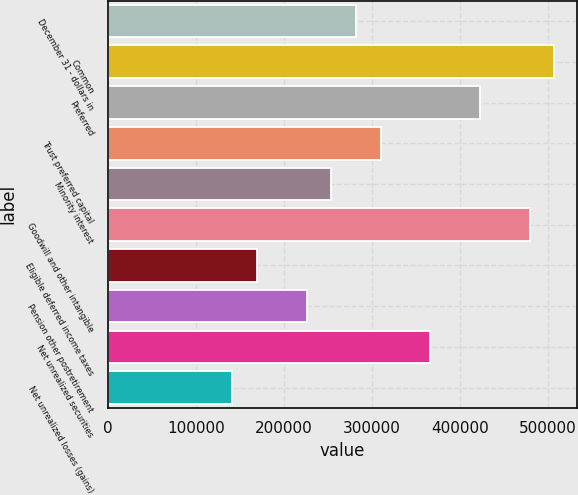<chart> <loc_0><loc_0><loc_500><loc_500><bar_chart><fcel>December 31 - dollars in<fcel>Common<fcel>Preferred<fcel>Trust preferred capital<fcel>Minority interest<fcel>Goodwill and other intangible<fcel>Eligible deferred income taxes<fcel>Pension other postretirement<fcel>Net unrealized securities<fcel>Net unrealized losses (gains)<nl><fcel>281874<fcel>507371<fcel>422810<fcel>310061<fcel>253687<fcel>479184<fcel>169126<fcel>225500<fcel>366435<fcel>140938<nl></chart> 